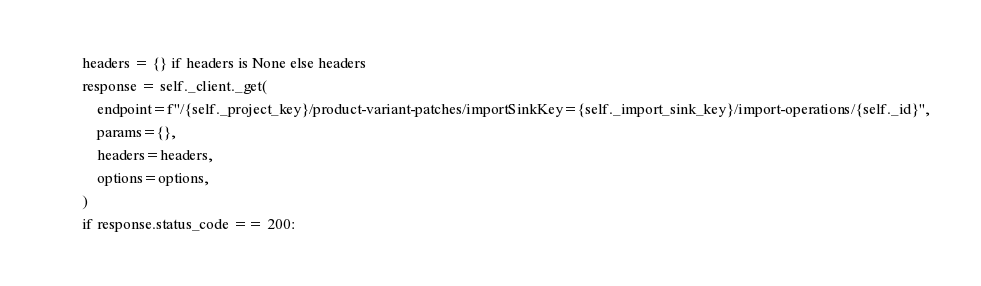Convert code to text. <code><loc_0><loc_0><loc_500><loc_500><_Python_>        headers = {} if headers is None else headers
        response = self._client._get(
            endpoint=f"/{self._project_key}/product-variant-patches/importSinkKey={self._import_sink_key}/import-operations/{self._id}",
            params={},
            headers=headers,
            options=options,
        )
        if response.status_code == 200:</code> 